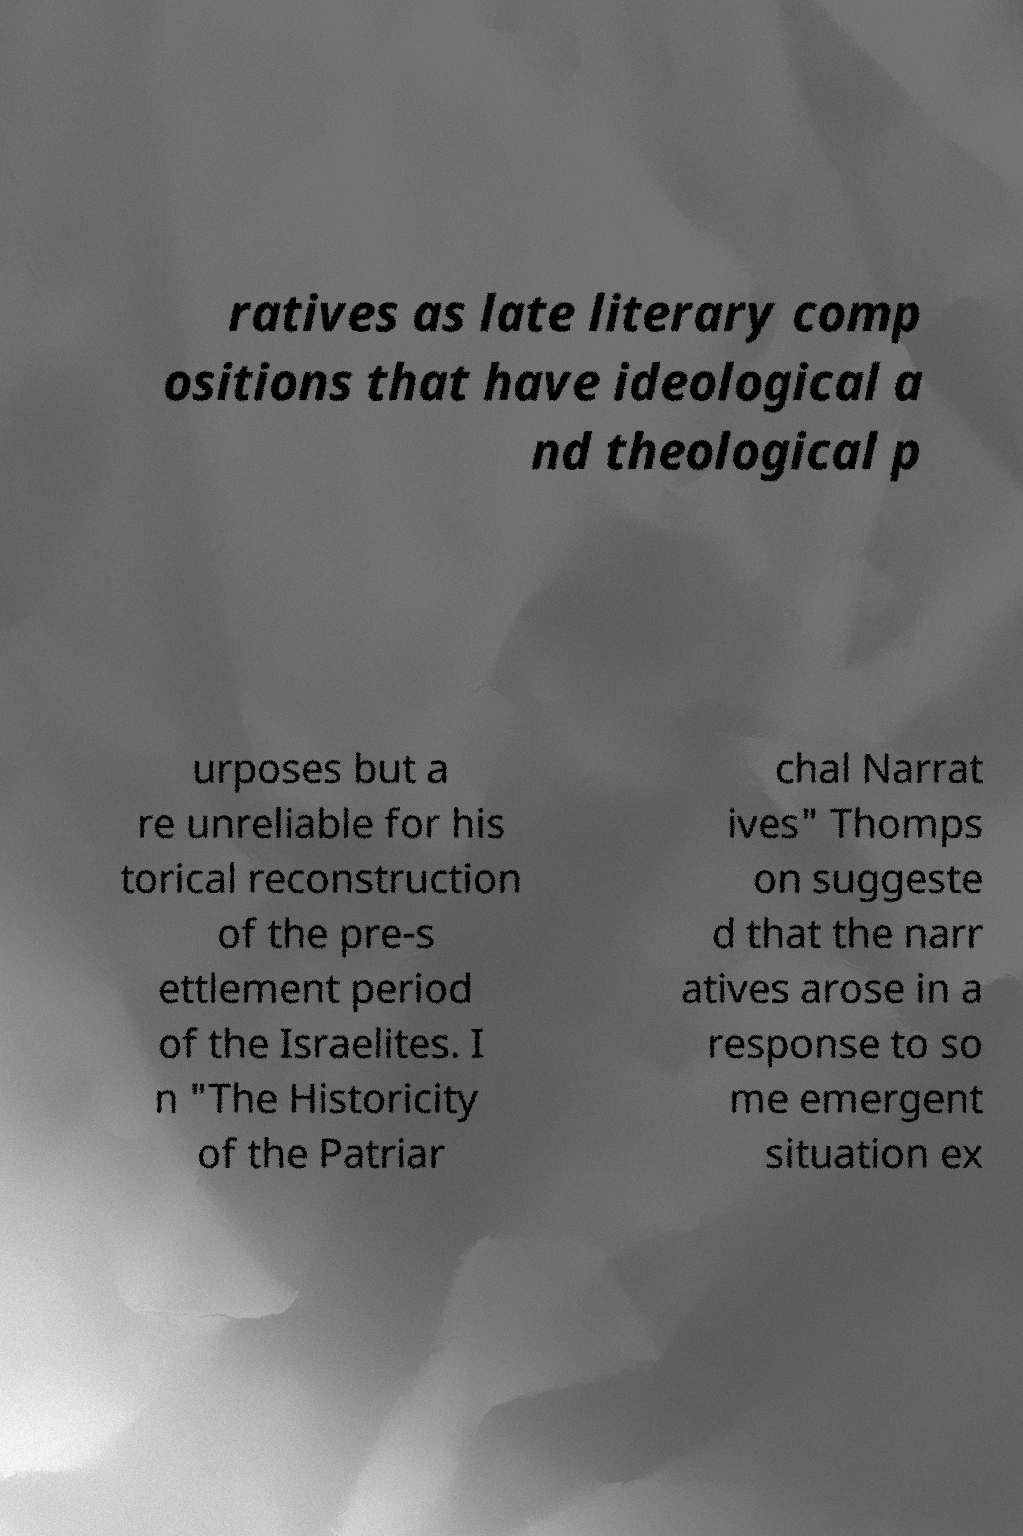Could you extract and type out the text from this image? ratives as late literary comp ositions that have ideological a nd theological p urposes but a re unreliable for his torical reconstruction of the pre-s ettlement period of the Israelites. I n "The Historicity of the Patriar chal Narrat ives" Thomps on suggeste d that the narr atives arose in a response to so me emergent situation ex 